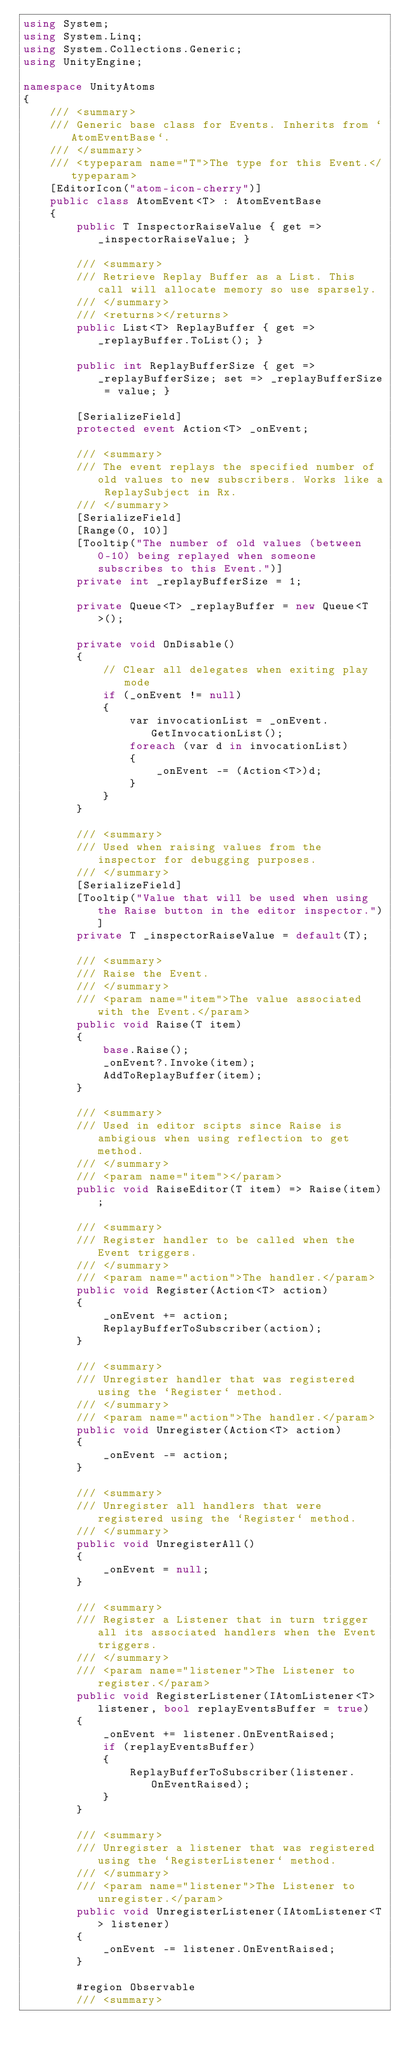<code> <loc_0><loc_0><loc_500><loc_500><_C#_>using System;
using System.Linq;
using System.Collections.Generic;
using UnityEngine;

namespace UnityAtoms
{
    /// <summary>
    /// Generic base class for Events. Inherits from `AtomEventBase`.
    /// </summary>
    /// <typeparam name="T">The type for this Event.</typeparam>
    [EditorIcon("atom-icon-cherry")]
    public class AtomEvent<T> : AtomEventBase
    {
        public T InspectorRaiseValue { get => _inspectorRaiseValue; }

        /// <summary>
        /// Retrieve Replay Buffer as a List. This call will allocate memory so use sparsely.
        /// </summary>
        /// <returns></returns>
        public List<T> ReplayBuffer { get => _replayBuffer.ToList(); }

        public int ReplayBufferSize { get => _replayBufferSize; set => _replayBufferSize = value; }

        [SerializeField]
        protected event Action<T> _onEvent;

        /// <summary>
        /// The event replays the specified number of old values to new subscribers. Works like a ReplaySubject in Rx. 
        /// </summary>
        [SerializeField]
        [Range(0, 10)]
        [Tooltip("The number of old values (between 0-10) being replayed when someone subscribes to this Event.")]
        private int _replayBufferSize = 1;

        private Queue<T> _replayBuffer = new Queue<T>();

        private void OnDisable()
        {
            // Clear all delegates when exiting play mode
            if (_onEvent != null)
            {
                var invocationList = _onEvent.GetInvocationList();
                foreach (var d in invocationList)
                {
                    _onEvent -= (Action<T>)d;
                }
            }
        }

        /// <summary>
        /// Used when raising values from the inspector for debugging purposes.
        /// </summary>
        [SerializeField]
        [Tooltip("Value that will be used when using the Raise button in the editor inspector.")]
        private T _inspectorRaiseValue = default(T);

        /// <summary>
        /// Raise the Event.
        /// </summary>
        /// <param name="item">The value associated with the Event.</param>
        public void Raise(T item)
        {
            base.Raise();
            _onEvent?.Invoke(item);
            AddToReplayBuffer(item);
        }

        /// <summary>
        /// Used in editor scipts since Raise is ambigious when using reflection to get method.
        /// </summary>
        /// <param name="item"></param>
        public void RaiseEditor(T item) => Raise(item);

        /// <summary>
        /// Register handler to be called when the Event triggers.
        /// </summary>
        /// <param name="action">The handler.</param>
        public void Register(Action<T> action)
        {
            _onEvent += action;
            ReplayBufferToSubscriber(action);
        }

        /// <summary>
        /// Unregister handler that was registered using the `Register` method.
        /// </summary>
        /// <param name="action">The handler.</param>
        public void Unregister(Action<T> action)
        {
            _onEvent -= action;
        }

        /// <summary>
        /// Unregister all handlers that were registered using the `Register` method.
        /// </summary>
        public void UnregisterAll()
        {
            _onEvent = null;
        }

        /// <summary>
        /// Register a Listener that in turn trigger all its associated handlers when the Event triggers.
        /// </summary>
        /// <param name="listener">The Listener to register.</param>
        public void RegisterListener(IAtomListener<T> listener, bool replayEventsBuffer = true)
        {
            _onEvent += listener.OnEventRaised;
            if (replayEventsBuffer)
            {
                ReplayBufferToSubscriber(listener.OnEventRaised);
            }
        }

        /// <summary>
        /// Unregister a listener that was registered using the `RegisterListener` method.
        /// </summary>
        /// <param name="listener">The Listener to unregister.</param>
        public void UnregisterListener(IAtomListener<T> listener)
        {
            _onEvent -= listener.OnEventRaised;
        }

        #region Observable
        /// <summary></code> 